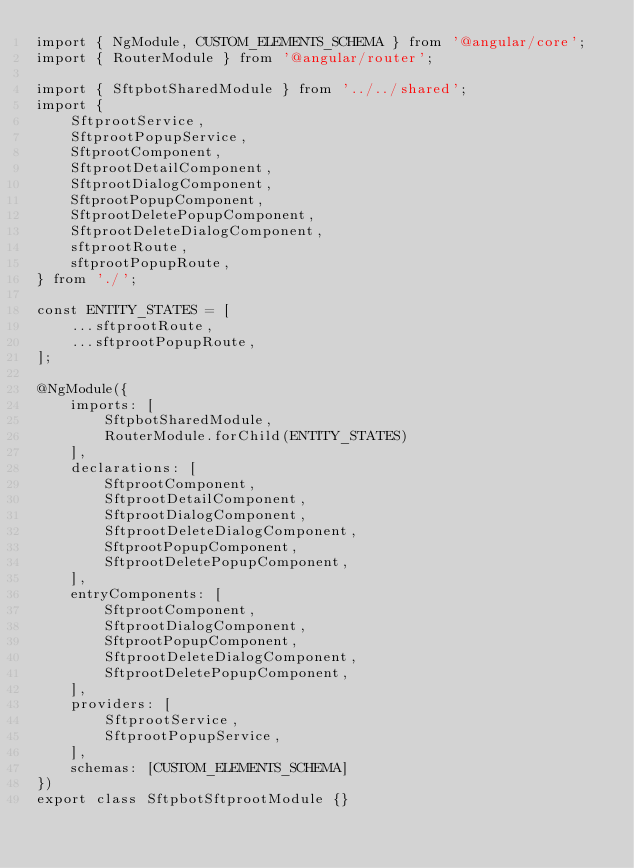<code> <loc_0><loc_0><loc_500><loc_500><_TypeScript_>import { NgModule, CUSTOM_ELEMENTS_SCHEMA } from '@angular/core';
import { RouterModule } from '@angular/router';

import { SftpbotSharedModule } from '../../shared';
import {
    SftprootService,
    SftprootPopupService,
    SftprootComponent,
    SftprootDetailComponent,
    SftprootDialogComponent,
    SftprootPopupComponent,
    SftprootDeletePopupComponent,
    SftprootDeleteDialogComponent,
    sftprootRoute,
    sftprootPopupRoute,
} from './';

const ENTITY_STATES = [
    ...sftprootRoute,
    ...sftprootPopupRoute,
];

@NgModule({
    imports: [
        SftpbotSharedModule,
        RouterModule.forChild(ENTITY_STATES)
    ],
    declarations: [
        SftprootComponent,
        SftprootDetailComponent,
        SftprootDialogComponent,
        SftprootDeleteDialogComponent,
        SftprootPopupComponent,
        SftprootDeletePopupComponent,
    ],
    entryComponents: [
        SftprootComponent,
        SftprootDialogComponent,
        SftprootPopupComponent,
        SftprootDeleteDialogComponent,
        SftprootDeletePopupComponent,
    ],
    providers: [
        SftprootService,
        SftprootPopupService,
    ],
    schemas: [CUSTOM_ELEMENTS_SCHEMA]
})
export class SftpbotSftprootModule {}
</code> 